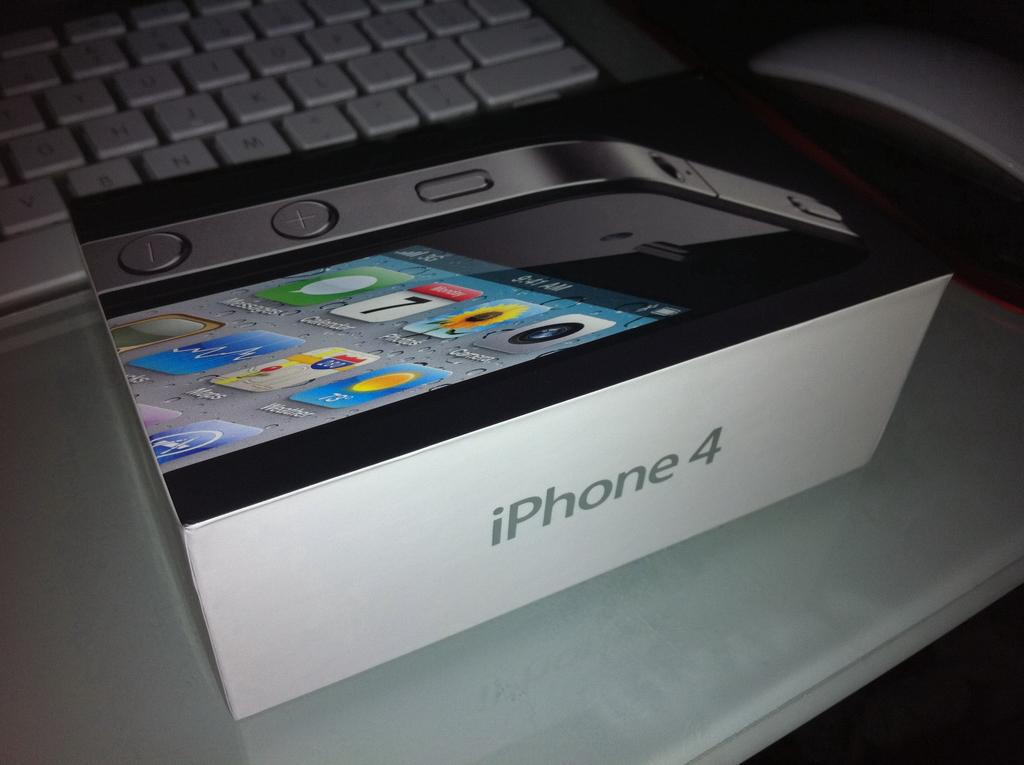<image>
Render a clear and concise summary of the photo. A box containing a cellphone labeled iphone 4 